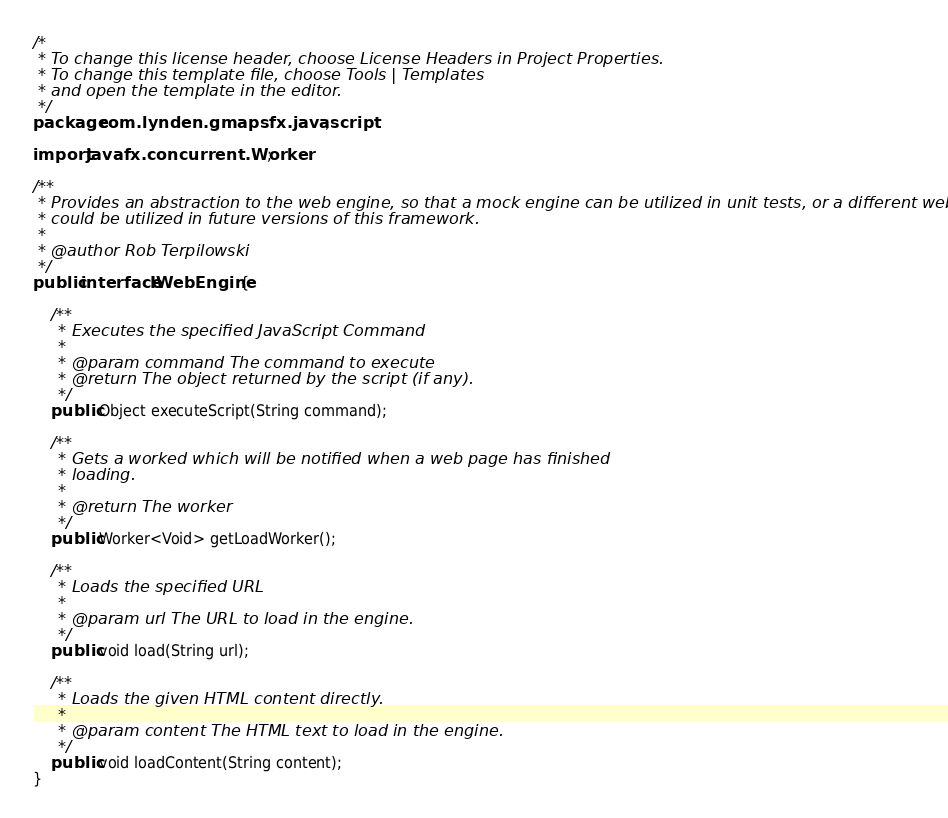Convert code to text. <code><loc_0><loc_0><loc_500><loc_500><_Java_>/*
 * To change this license header, choose License Headers in Project Properties.
 * To change this template file, choose Tools | Templates
 * and open the template in the editor.
 */
package com.lynden.gmapsfx.javascript;

import javafx.concurrent.Worker;

/**
 * Provides an abstraction to the web engine, so that a mock engine can be utilized in unit tests, or a different web engine
 * could be utilized in future versions of this framework.
 * 
 * @author Rob Terpilowski
 */
public interface IWebEngine {

    /**
     * Executes the specified JavaScript Command
     *
     * @param command The command to execute
     * @return The object returned by the script (if any).
     */
    public Object executeScript(String command);

    /**
     * Gets a worked which will be notified when a web page has finished
     * loading.
     *
     * @return The worker
     */
    public Worker<Void> getLoadWorker();

    /**
     * Loads the specified URL
     *
     * @param url The URL to load in the engine.
     */
    public void load(String url);

    /**
     * Loads the given HTML content directly.
     *
     * @param content The HTML text to load in the engine.
     */
    public void loadContent(String content);
}
</code> 